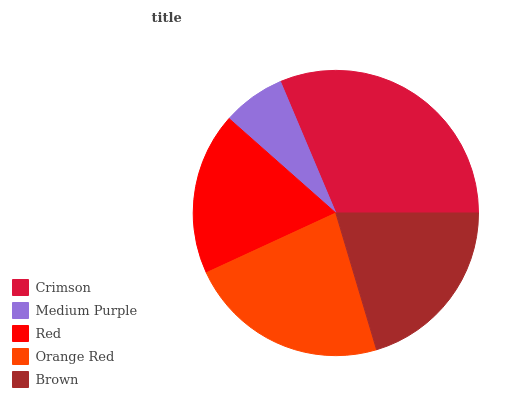Is Medium Purple the minimum?
Answer yes or no. Yes. Is Crimson the maximum?
Answer yes or no. Yes. Is Red the minimum?
Answer yes or no. No. Is Red the maximum?
Answer yes or no. No. Is Red greater than Medium Purple?
Answer yes or no. Yes. Is Medium Purple less than Red?
Answer yes or no. Yes. Is Medium Purple greater than Red?
Answer yes or no. No. Is Red less than Medium Purple?
Answer yes or no. No. Is Brown the high median?
Answer yes or no. Yes. Is Brown the low median?
Answer yes or no. Yes. Is Crimson the high median?
Answer yes or no. No. Is Medium Purple the low median?
Answer yes or no. No. 